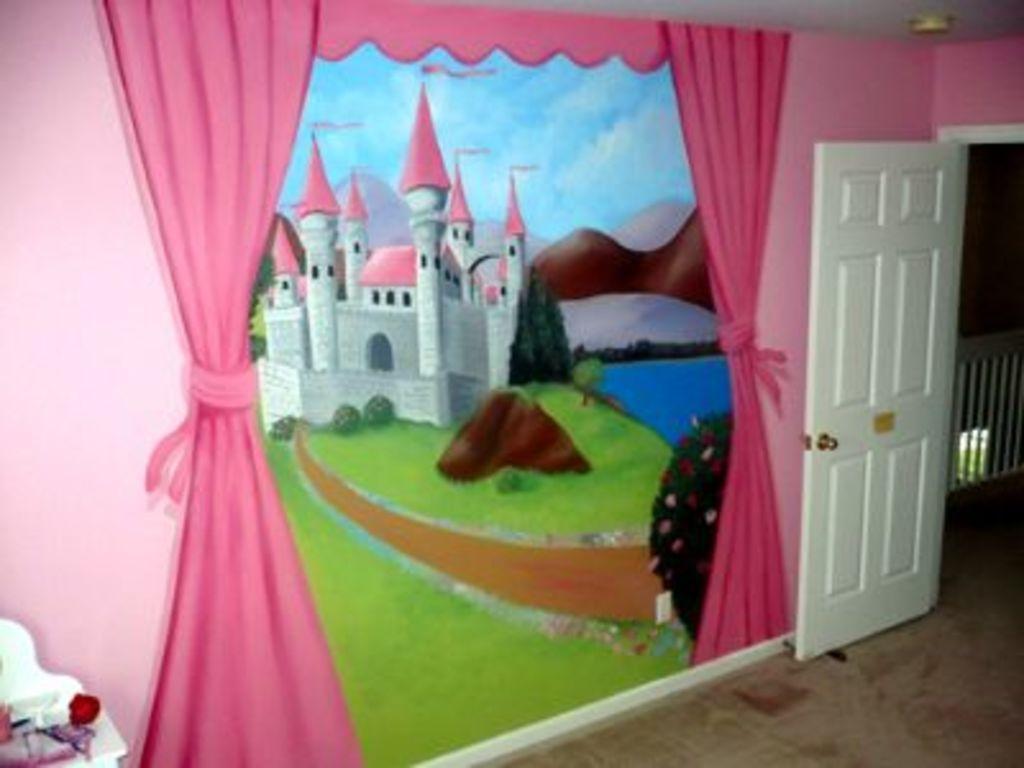Describe this image in one or two sentences. In this picture I can see there is an image of a fort, pond, fort and a mountain. There is a curtain and a door at the right side. 